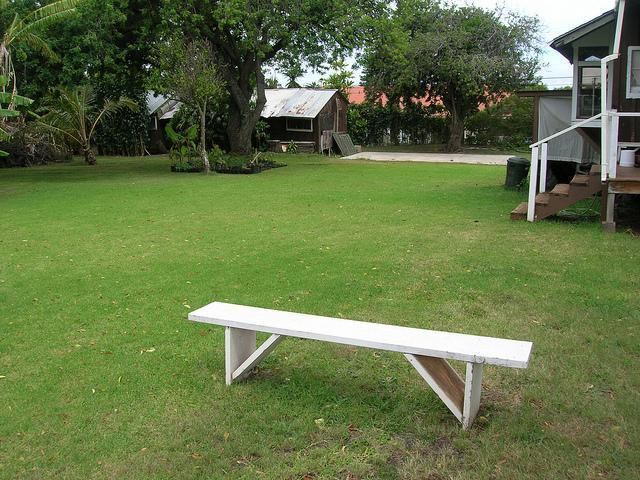How many people are walking?
Give a very brief answer. 0. 